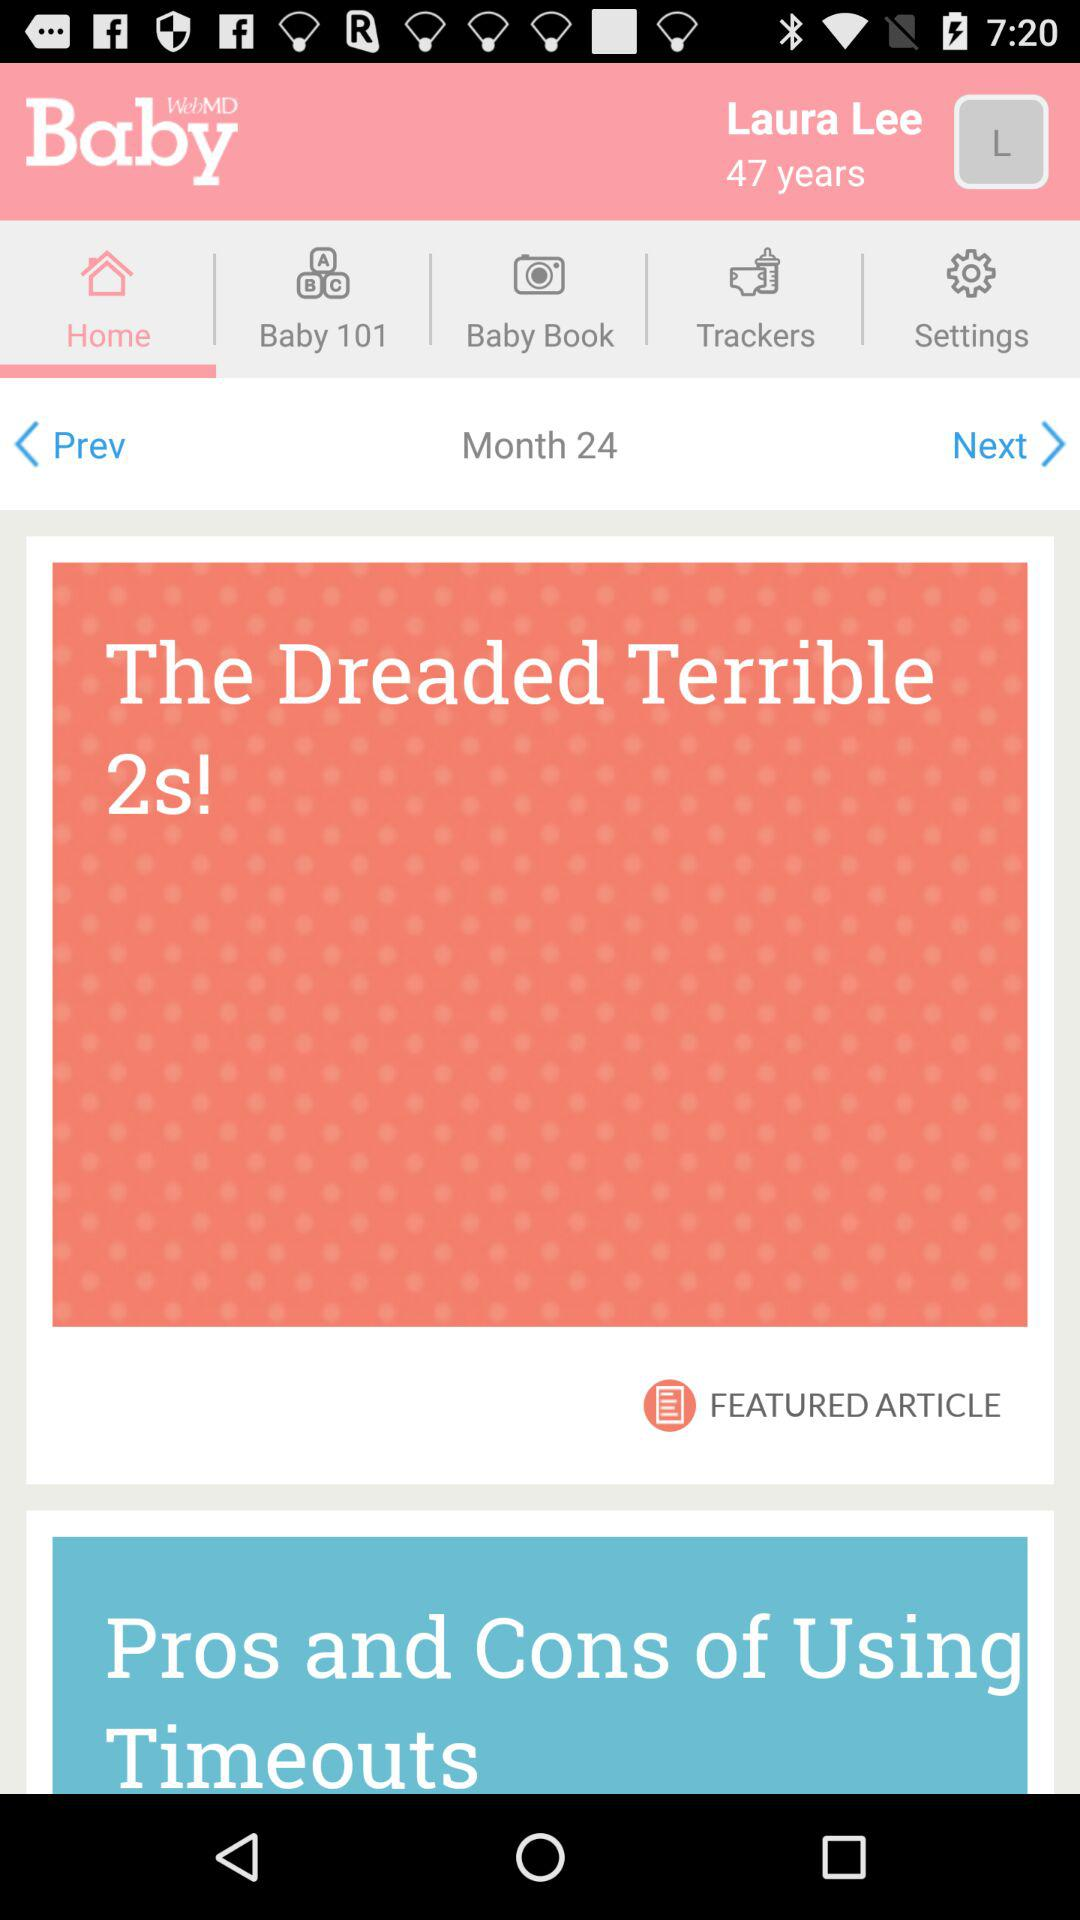What's the user name? The user name is Laura Lee. 